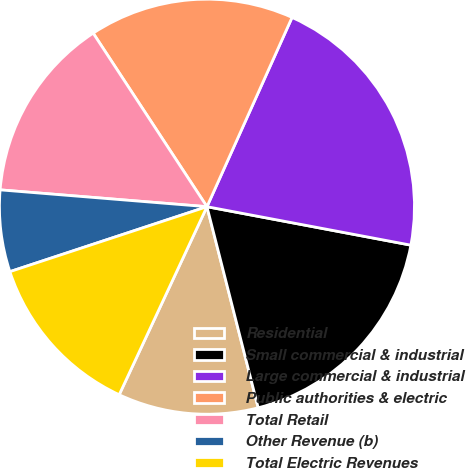<chart> <loc_0><loc_0><loc_500><loc_500><pie_chart><fcel>Residential<fcel>Small commercial & industrial<fcel>Large commercial & industrial<fcel>Public authorities & electric<fcel>Total Retail<fcel>Other Revenue (b)<fcel>Total Electric Revenues<nl><fcel>10.92%<fcel>18.06%<fcel>21.24%<fcel>15.96%<fcel>14.47%<fcel>6.36%<fcel>12.98%<nl></chart> 